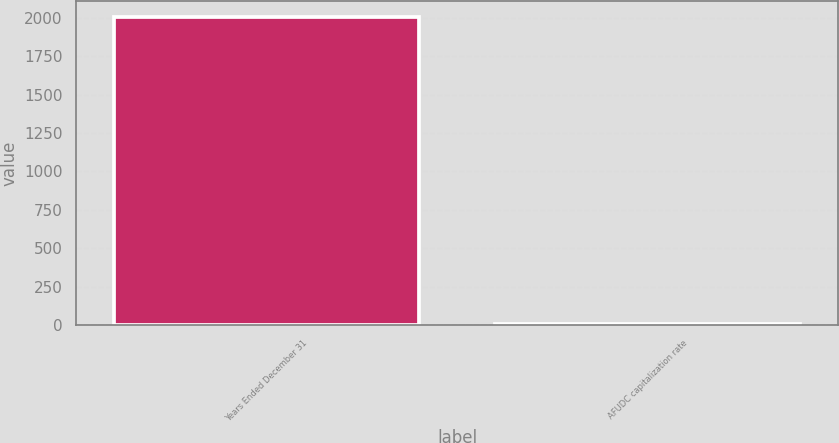<chart> <loc_0><loc_0><loc_500><loc_500><bar_chart><fcel>Years Ended December 31<fcel>AFUDC capitalization rate<nl><fcel>2008<fcel>7.7<nl></chart> 